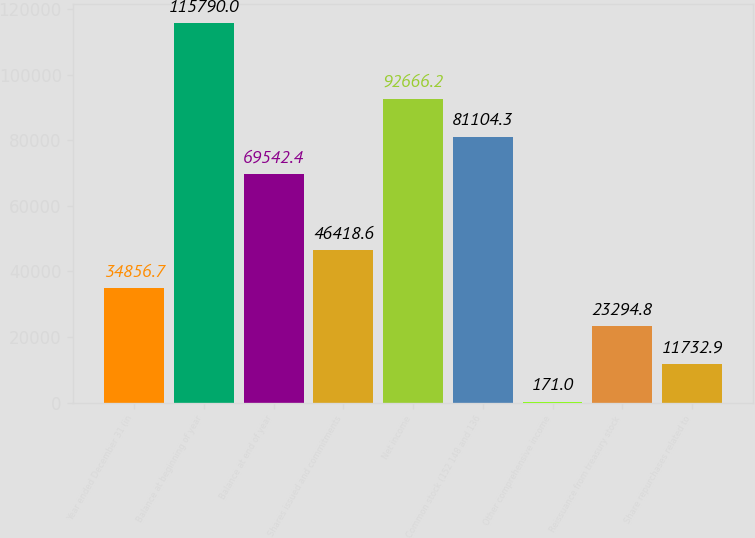<chart> <loc_0><loc_0><loc_500><loc_500><bar_chart><fcel>Year ended December 31 (in<fcel>Balance at beginning of year<fcel>Balance at end of year<fcel>Shares issued and commitments<fcel>Net income<fcel>Common stock (152 148 and 136<fcel>Other comprehensive income<fcel>Reissuance from treasury stock<fcel>Share repurchases related to<nl><fcel>34856.7<fcel>115790<fcel>69542.4<fcel>46418.6<fcel>92666.2<fcel>81104.3<fcel>171<fcel>23294.8<fcel>11732.9<nl></chart> 